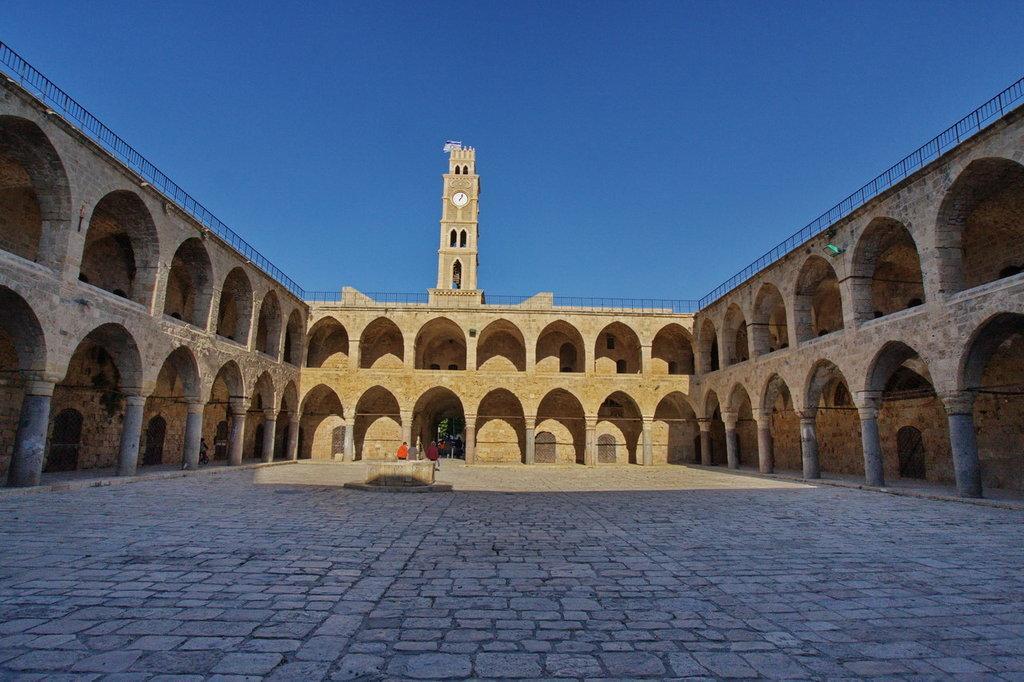Describe this image in one or two sentences. In this image I can see an ancient architecture and in the background I can see a clock tower. I can also see few people in the background and on the top of this image I can see the sky. On the right side I can see a light. 